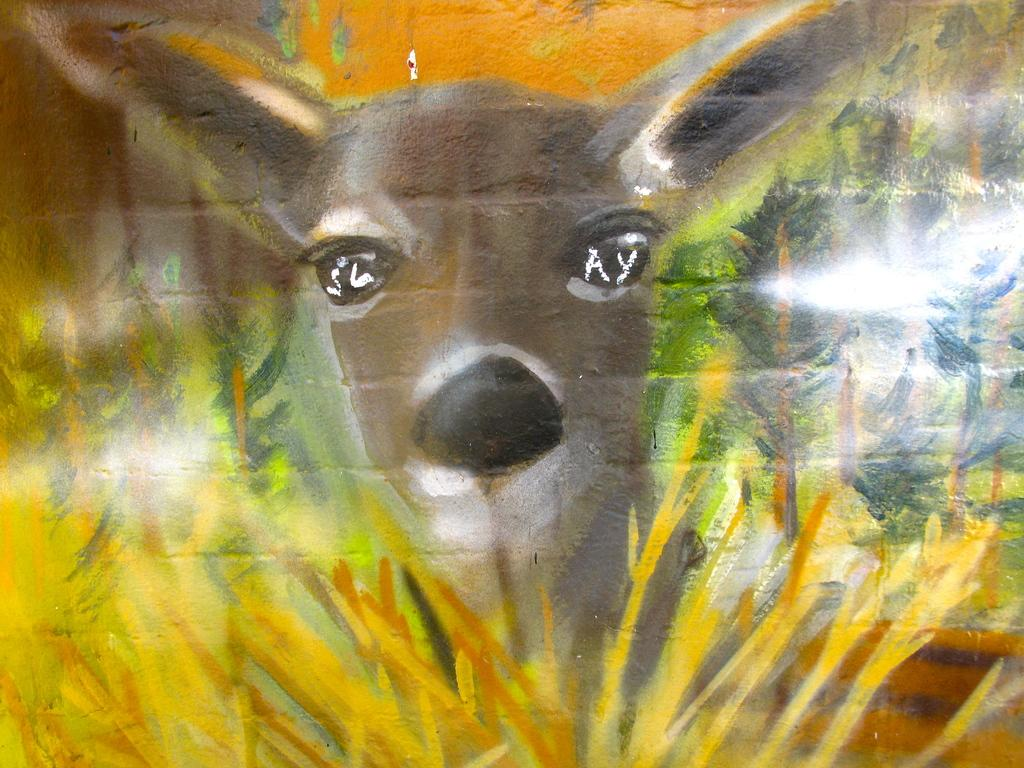What is the main subject of the painting in the image? The painting depicts deer. What other elements are present in the painting? The painting also depicts trees. Where is the painting located in the image? The painting is on a wall. What type of ink was used to create the painting in the image? There is no information about the type of ink used in the painting, as the facts provided do not mention it. 